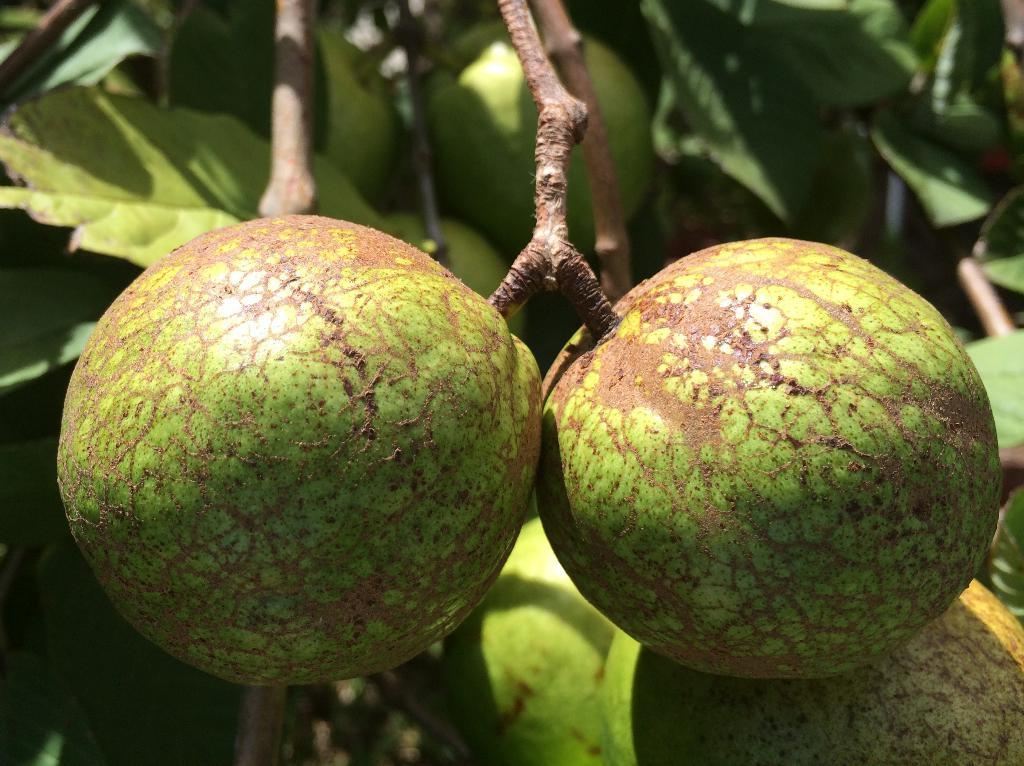What can be seen in the image? There is a tree in the image. What is on the tree? There are fruits on the tree. What type of pipe is visible in the image? There is no pipe present in the image; it only features a tree with fruits. What is the goat doing in the image? There is no goat present in the image; it only features a tree with fruits. 